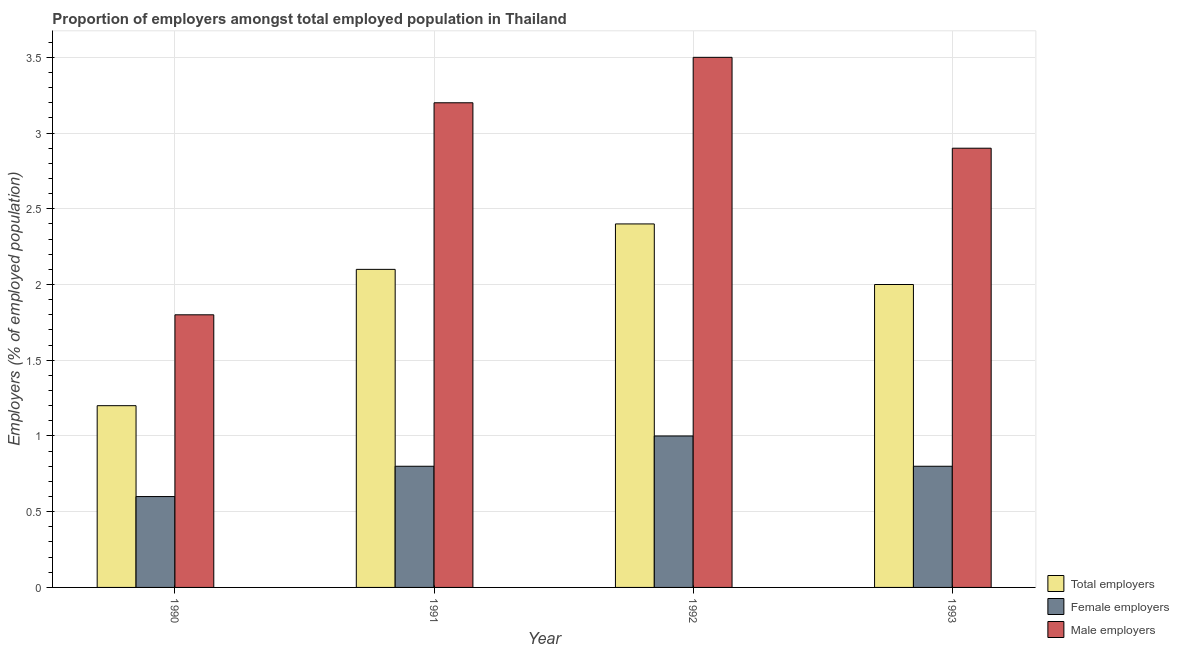How many different coloured bars are there?
Keep it short and to the point. 3. Are the number of bars on each tick of the X-axis equal?
Your answer should be very brief. Yes. How many bars are there on the 2nd tick from the left?
Your response must be concise. 3. How many bars are there on the 1st tick from the right?
Provide a short and direct response. 3. What is the percentage of male employers in 1993?
Give a very brief answer. 2.9. Across all years, what is the maximum percentage of total employers?
Your answer should be very brief. 2.4. Across all years, what is the minimum percentage of female employers?
Keep it short and to the point. 0.6. What is the total percentage of total employers in the graph?
Ensure brevity in your answer.  7.7. What is the difference between the percentage of male employers in 1990 and that in 1993?
Give a very brief answer. -1.1. What is the difference between the percentage of male employers in 1993 and the percentage of total employers in 1992?
Your answer should be compact. -0.6. What is the average percentage of female employers per year?
Your response must be concise. 0.8. In the year 1992, what is the difference between the percentage of female employers and percentage of male employers?
Provide a succinct answer. 0. What is the ratio of the percentage of total employers in 1990 to that in 1993?
Your answer should be very brief. 0.6. What is the difference between the highest and the second highest percentage of female employers?
Your response must be concise. 0.2. What is the difference between the highest and the lowest percentage of total employers?
Your answer should be compact. 1.2. In how many years, is the percentage of female employers greater than the average percentage of female employers taken over all years?
Give a very brief answer. 1. What does the 2nd bar from the left in 1993 represents?
Make the answer very short. Female employers. What does the 3rd bar from the right in 1993 represents?
Your answer should be very brief. Total employers. Is it the case that in every year, the sum of the percentage of total employers and percentage of female employers is greater than the percentage of male employers?
Provide a succinct answer. No. What is the difference between two consecutive major ticks on the Y-axis?
Provide a short and direct response. 0.5. Are the values on the major ticks of Y-axis written in scientific E-notation?
Offer a very short reply. No. Does the graph contain any zero values?
Keep it short and to the point. No. Does the graph contain grids?
Provide a succinct answer. Yes. How many legend labels are there?
Keep it short and to the point. 3. What is the title of the graph?
Ensure brevity in your answer.  Proportion of employers amongst total employed population in Thailand. What is the label or title of the X-axis?
Give a very brief answer. Year. What is the label or title of the Y-axis?
Make the answer very short. Employers (% of employed population). What is the Employers (% of employed population) of Total employers in 1990?
Provide a succinct answer. 1.2. What is the Employers (% of employed population) in Female employers in 1990?
Your response must be concise. 0.6. What is the Employers (% of employed population) of Male employers in 1990?
Offer a terse response. 1.8. What is the Employers (% of employed population) in Total employers in 1991?
Your answer should be very brief. 2.1. What is the Employers (% of employed population) of Female employers in 1991?
Your answer should be very brief. 0.8. What is the Employers (% of employed population) in Male employers in 1991?
Offer a terse response. 3.2. What is the Employers (% of employed population) of Total employers in 1992?
Your answer should be compact. 2.4. What is the Employers (% of employed population) of Female employers in 1993?
Give a very brief answer. 0.8. What is the Employers (% of employed population) in Male employers in 1993?
Give a very brief answer. 2.9. Across all years, what is the maximum Employers (% of employed population) of Total employers?
Your answer should be compact. 2.4. Across all years, what is the maximum Employers (% of employed population) in Male employers?
Your answer should be compact. 3.5. Across all years, what is the minimum Employers (% of employed population) in Total employers?
Your response must be concise. 1.2. Across all years, what is the minimum Employers (% of employed population) in Female employers?
Make the answer very short. 0.6. Across all years, what is the minimum Employers (% of employed population) in Male employers?
Your response must be concise. 1.8. What is the total Employers (% of employed population) of Female employers in the graph?
Your answer should be compact. 3.2. What is the total Employers (% of employed population) in Male employers in the graph?
Provide a short and direct response. 11.4. What is the difference between the Employers (% of employed population) of Male employers in 1990 and that in 1991?
Your answer should be very brief. -1.4. What is the difference between the Employers (% of employed population) in Total employers in 1990 and that in 1992?
Offer a terse response. -1.2. What is the difference between the Employers (% of employed population) of Female employers in 1990 and that in 1992?
Offer a very short reply. -0.4. What is the difference between the Employers (% of employed population) of Male employers in 1990 and that in 1992?
Ensure brevity in your answer.  -1.7. What is the difference between the Employers (% of employed population) in Total employers in 1990 and that in 1993?
Give a very brief answer. -0.8. What is the difference between the Employers (% of employed population) in Female employers in 1990 and that in 1993?
Provide a short and direct response. -0.2. What is the difference between the Employers (% of employed population) in Male employers in 1990 and that in 1993?
Offer a very short reply. -1.1. What is the difference between the Employers (% of employed population) in Total employers in 1991 and that in 1992?
Your response must be concise. -0.3. What is the difference between the Employers (% of employed population) in Male employers in 1991 and that in 1993?
Ensure brevity in your answer.  0.3. What is the difference between the Employers (% of employed population) in Female employers in 1992 and that in 1993?
Provide a succinct answer. 0.2. What is the difference between the Employers (% of employed population) in Total employers in 1990 and the Employers (% of employed population) in Female employers in 1991?
Provide a succinct answer. 0.4. What is the difference between the Employers (% of employed population) of Total employers in 1990 and the Employers (% of employed population) of Female employers in 1992?
Make the answer very short. 0.2. What is the difference between the Employers (% of employed population) in Total employers in 1990 and the Employers (% of employed population) in Male employers in 1992?
Provide a succinct answer. -2.3. What is the difference between the Employers (% of employed population) of Female employers in 1990 and the Employers (% of employed population) of Male employers in 1992?
Make the answer very short. -2.9. What is the difference between the Employers (% of employed population) in Total employers in 1990 and the Employers (% of employed population) in Female employers in 1993?
Your answer should be very brief. 0.4. What is the difference between the Employers (% of employed population) in Female employers in 1990 and the Employers (% of employed population) in Male employers in 1993?
Your answer should be very brief. -2.3. What is the difference between the Employers (% of employed population) of Total employers in 1991 and the Employers (% of employed population) of Female employers in 1992?
Provide a succinct answer. 1.1. What is the difference between the Employers (% of employed population) in Total employers in 1991 and the Employers (% of employed population) in Male employers in 1992?
Offer a very short reply. -1.4. What is the difference between the Employers (% of employed population) of Female employers in 1991 and the Employers (% of employed population) of Male employers in 1992?
Give a very brief answer. -2.7. What is the difference between the Employers (% of employed population) in Total employers in 1991 and the Employers (% of employed population) in Female employers in 1993?
Give a very brief answer. 1.3. What is the difference between the Employers (% of employed population) of Total employers in 1991 and the Employers (% of employed population) of Male employers in 1993?
Provide a succinct answer. -0.8. What is the difference between the Employers (% of employed population) in Total employers in 1992 and the Employers (% of employed population) in Female employers in 1993?
Your response must be concise. 1.6. What is the average Employers (% of employed population) of Total employers per year?
Your answer should be compact. 1.93. What is the average Employers (% of employed population) in Male employers per year?
Give a very brief answer. 2.85. In the year 1990, what is the difference between the Employers (% of employed population) of Total employers and Employers (% of employed population) of Female employers?
Your response must be concise. 0.6. In the year 1991, what is the difference between the Employers (% of employed population) in Total employers and Employers (% of employed population) in Female employers?
Offer a terse response. 1.3. In the year 1991, what is the difference between the Employers (% of employed population) of Total employers and Employers (% of employed population) of Male employers?
Make the answer very short. -1.1. In the year 1991, what is the difference between the Employers (% of employed population) of Female employers and Employers (% of employed population) of Male employers?
Give a very brief answer. -2.4. In the year 1992, what is the difference between the Employers (% of employed population) in Total employers and Employers (% of employed population) in Female employers?
Offer a terse response. 1.4. What is the ratio of the Employers (% of employed population) of Female employers in 1990 to that in 1991?
Provide a short and direct response. 0.75. What is the ratio of the Employers (% of employed population) of Male employers in 1990 to that in 1991?
Offer a very short reply. 0.56. What is the ratio of the Employers (% of employed population) in Total employers in 1990 to that in 1992?
Ensure brevity in your answer.  0.5. What is the ratio of the Employers (% of employed population) in Female employers in 1990 to that in 1992?
Provide a succinct answer. 0.6. What is the ratio of the Employers (% of employed population) of Male employers in 1990 to that in 1992?
Your answer should be compact. 0.51. What is the ratio of the Employers (% of employed population) in Female employers in 1990 to that in 1993?
Your response must be concise. 0.75. What is the ratio of the Employers (% of employed population) of Male employers in 1990 to that in 1993?
Make the answer very short. 0.62. What is the ratio of the Employers (% of employed population) of Male employers in 1991 to that in 1992?
Your response must be concise. 0.91. What is the ratio of the Employers (% of employed population) in Male employers in 1991 to that in 1993?
Your answer should be very brief. 1.1. What is the ratio of the Employers (% of employed population) of Total employers in 1992 to that in 1993?
Provide a succinct answer. 1.2. What is the ratio of the Employers (% of employed population) in Female employers in 1992 to that in 1993?
Offer a very short reply. 1.25. What is the ratio of the Employers (% of employed population) in Male employers in 1992 to that in 1993?
Your response must be concise. 1.21. What is the difference between the highest and the second highest Employers (% of employed population) of Total employers?
Your answer should be very brief. 0.3. What is the difference between the highest and the second highest Employers (% of employed population) in Female employers?
Provide a succinct answer. 0.2. What is the difference between the highest and the second highest Employers (% of employed population) of Male employers?
Provide a short and direct response. 0.3. 